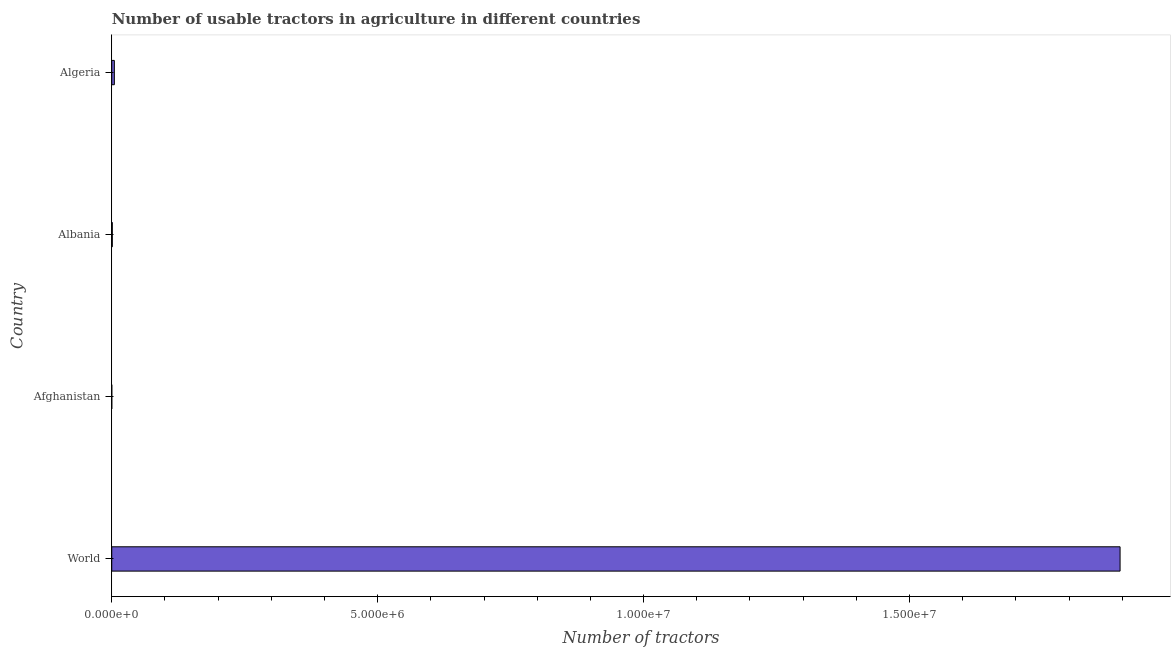Does the graph contain any zero values?
Offer a terse response. No. Does the graph contain grids?
Make the answer very short. No. What is the title of the graph?
Ensure brevity in your answer.  Number of usable tractors in agriculture in different countries. What is the label or title of the X-axis?
Offer a very short reply. Number of tractors. What is the number of tractors in World?
Your answer should be compact. 1.90e+07. Across all countries, what is the maximum number of tractors?
Ensure brevity in your answer.  1.90e+07. Across all countries, what is the minimum number of tractors?
Ensure brevity in your answer.  300. In which country was the number of tractors minimum?
Your response must be concise. Afghanistan. What is the sum of the number of tractors?
Ensure brevity in your answer.  1.90e+07. What is the difference between the number of tractors in Afghanistan and World?
Your answer should be very brief. -1.90e+07. What is the average number of tractors per country?
Provide a succinct answer. 4.75e+06. What is the median number of tractors?
Your answer should be compact. 2.98e+04. Is the number of tractors in Algeria less than that in World?
Ensure brevity in your answer.  Yes. What is the difference between the highest and the second highest number of tractors?
Provide a succinct answer. 1.89e+07. What is the difference between the highest and the lowest number of tractors?
Your answer should be compact. 1.90e+07. In how many countries, is the number of tractors greater than the average number of tractors taken over all countries?
Your answer should be very brief. 1. What is the difference between two consecutive major ticks on the X-axis?
Your answer should be very brief. 5.00e+06. Are the values on the major ticks of X-axis written in scientific E-notation?
Your response must be concise. Yes. What is the Number of tractors in World?
Offer a terse response. 1.90e+07. What is the Number of tractors of Afghanistan?
Give a very brief answer. 300. What is the Number of tractors of Albania?
Your response must be concise. 1.03e+04. What is the Number of tractors of Algeria?
Your answer should be compact. 4.92e+04. What is the difference between the Number of tractors in World and Afghanistan?
Provide a succinct answer. 1.90e+07. What is the difference between the Number of tractors in World and Albania?
Your answer should be very brief. 1.89e+07. What is the difference between the Number of tractors in World and Algeria?
Keep it short and to the point. 1.89e+07. What is the difference between the Number of tractors in Afghanistan and Albania?
Make the answer very short. -10000. What is the difference between the Number of tractors in Afghanistan and Algeria?
Provide a short and direct response. -4.89e+04. What is the difference between the Number of tractors in Albania and Algeria?
Offer a terse response. -3.89e+04. What is the ratio of the Number of tractors in World to that in Afghanistan?
Offer a very short reply. 6.32e+04. What is the ratio of the Number of tractors in World to that in Albania?
Offer a very short reply. 1840.68. What is the ratio of the Number of tractors in World to that in Algeria?
Keep it short and to the point. 385.35. What is the ratio of the Number of tractors in Afghanistan to that in Albania?
Your answer should be very brief. 0.03. What is the ratio of the Number of tractors in Afghanistan to that in Algeria?
Offer a terse response. 0.01. What is the ratio of the Number of tractors in Albania to that in Algeria?
Give a very brief answer. 0.21. 